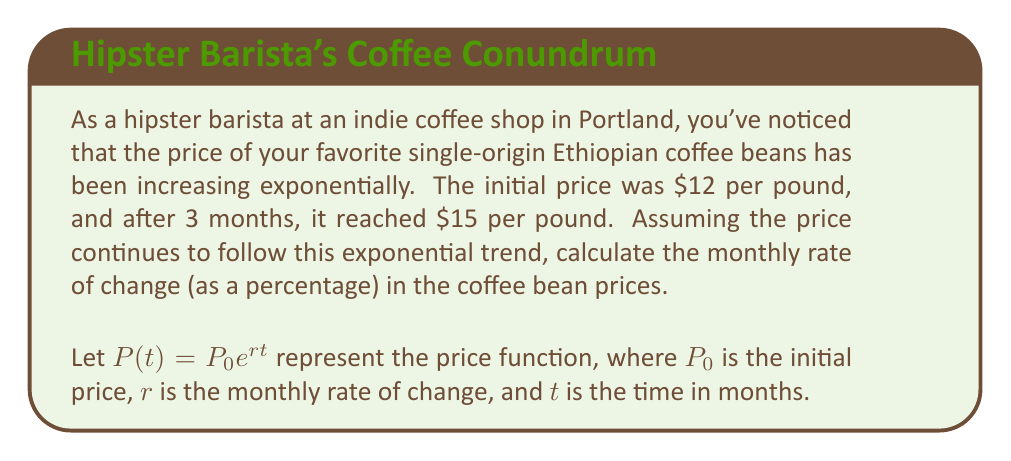Give your solution to this math problem. To solve this problem, we'll use the exponential growth formula:

$P(t) = P_0 e^{rt}$

Given:
- Initial price $P_0 = 12$
- Price after 3 months $P(3) = 15$
- Time $t = 3$ months

Step 1: Substitute the known values into the formula.
$15 = 12 e^{3r}$

Step 2: Divide both sides by 12.
$\frac{15}{12} = e^{3r}$

Step 3: Take the natural logarithm of both sides.
$\ln(\frac{15}{12}) = 3r$

Step 4: Solve for $r$.
$r = \frac{\ln(\frac{15}{12})}{3}$

Step 5: Calculate the value of $r$.
$r \approx 0.0739$

Step 6: Convert $r$ to a percentage.
$r \approx 0.0739 \times 100\% = 7.39\%$

Therefore, the monthly rate of change in coffee bean prices is approximately 7.39%.
Answer: 7.39% 